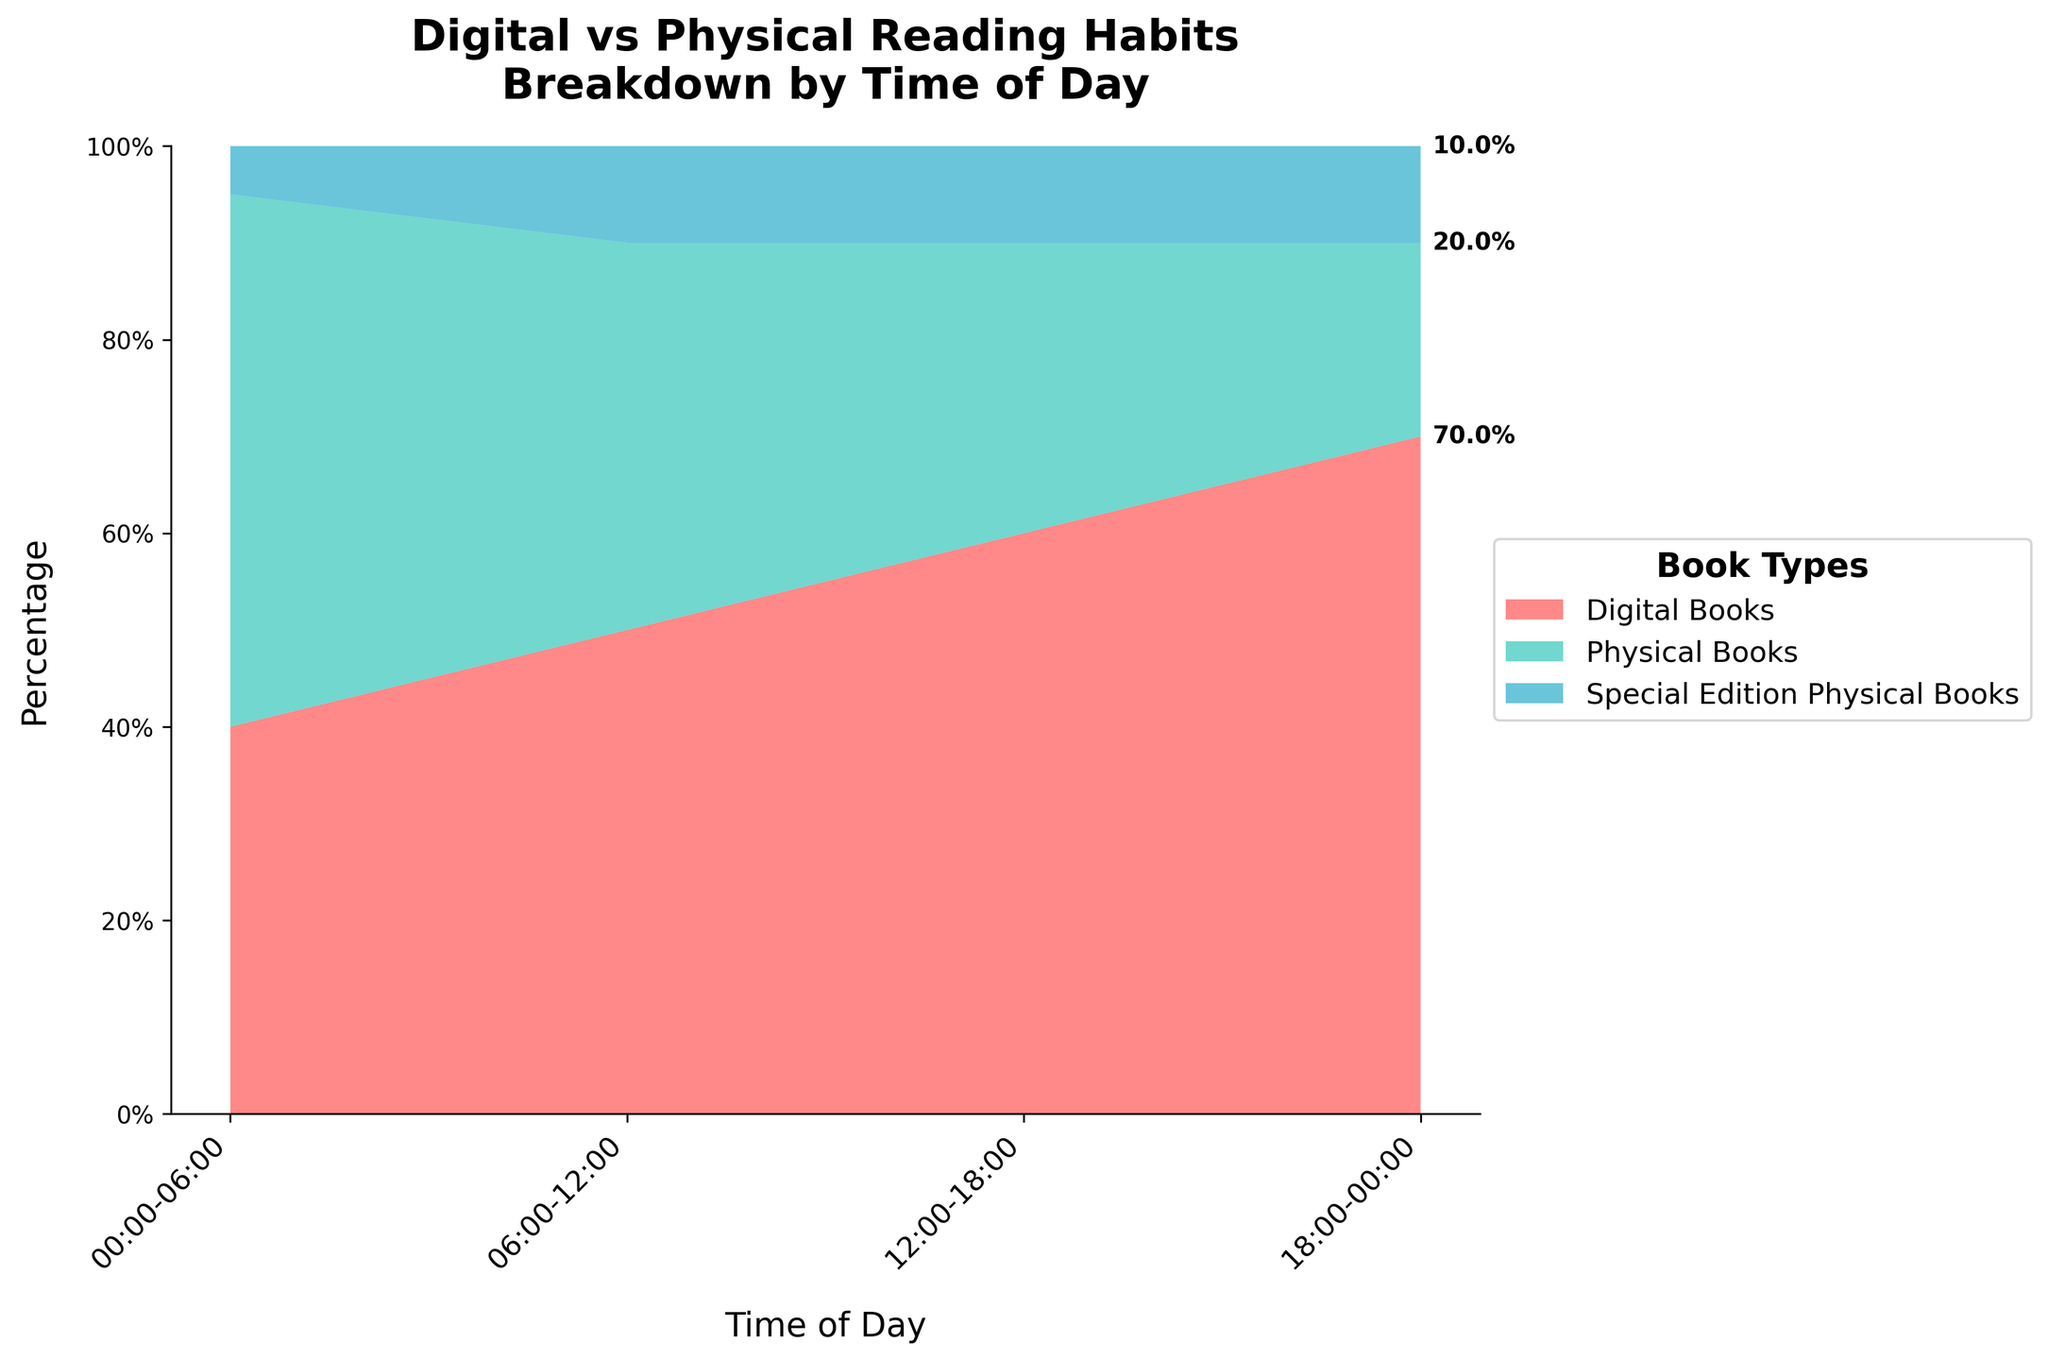What's the title of the chart? The title is usually found at the top of the chart and summarizes what the plot is about. In this case, it reads: "Digital vs Physical Reading Habits Breakdown by Time of Day".
Answer: Digital vs Physical Reading Habits Breakdown by Time of Day How many time intervals are shown in the chart? Count the distinct time intervals along the x-axis. There are four intervals indicated: 00:00-06:00, 06:00-12:00, 12:00-18:00, and 18:00-00:00.
Answer: 4 What are the three categories of books displayed in the chart? The legend to the right of the chart lists the three categories which differentiate the data. They are Digital Books, Physical Books, and Special Edition Physical Books.
Answer: Digital Books, Physical Books, Special Edition Physical Books During which time interval is the percentage of Digital Books the highest? By examining the stacked areas, the largest section of the Digital Books (color-coded) appears in the interval 18:00-00:00.
Answer: 18:00-00:00 Which category maintains a consistent percentage from 12:00 to 00:00? By analyzing the heights of the segments for each time interval, Special Edition Physical Books maintain a consistent height of 10% in the 12:00-18:00 and 18:00-00:00 intervals.
Answer: Special Edition Physical Books What is the average percentage of Physical Books between 06:00 and 18:00? From 06:00-12:00, Physical Books contribute 40%, and from 12:00-18:00, they contribute 30%. The average of these two values is (40% + 30%) / 2.
Answer: 35% Which category has the widest variation in percentage across different time intervals? By comparing the areas visually from one interval to another, Digital Books have the largest fluctuation from 40% (00:00-06:00) to 70% (18:00-00:00), displaying the most significant variation.
Answer: Digital Books What is the combined percentage of Special Edition Physical Books from 12:00 to 00:00? Since Special Edition Physical Books hold 10% in both 12:00-18:00 and 18:00-00:00 intervals, summing these gives 10% + 10%.
Answer: 20% At what time interval do Physical Books have the smallest percentage share? The smallest segment of the Physical Books area is during the 18:00-00:00 interval where they hold only 20%.
Answer: 18:00-00:00 How does the percentage of Digital Books change from 00:00-06:00 to 18:00-00:00? Visually track the area for Digital Books; it starts at 40% (00:00-06:00) and increases to 70% (18:00-00:00). The change is 70% - 40%.
Answer: Increases by 30% 